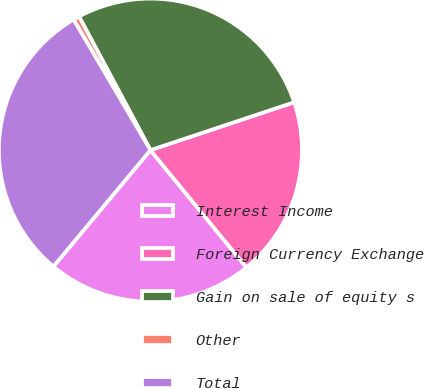Convert chart. <chart><loc_0><loc_0><loc_500><loc_500><pie_chart><fcel>Interest Income<fcel>Foreign Currency Exchange<fcel>Gain on sale of equity s<fcel>Other<fcel>Total<nl><fcel>21.98%<fcel>19.2%<fcel>27.69%<fcel>0.66%<fcel>30.47%<nl></chart> 